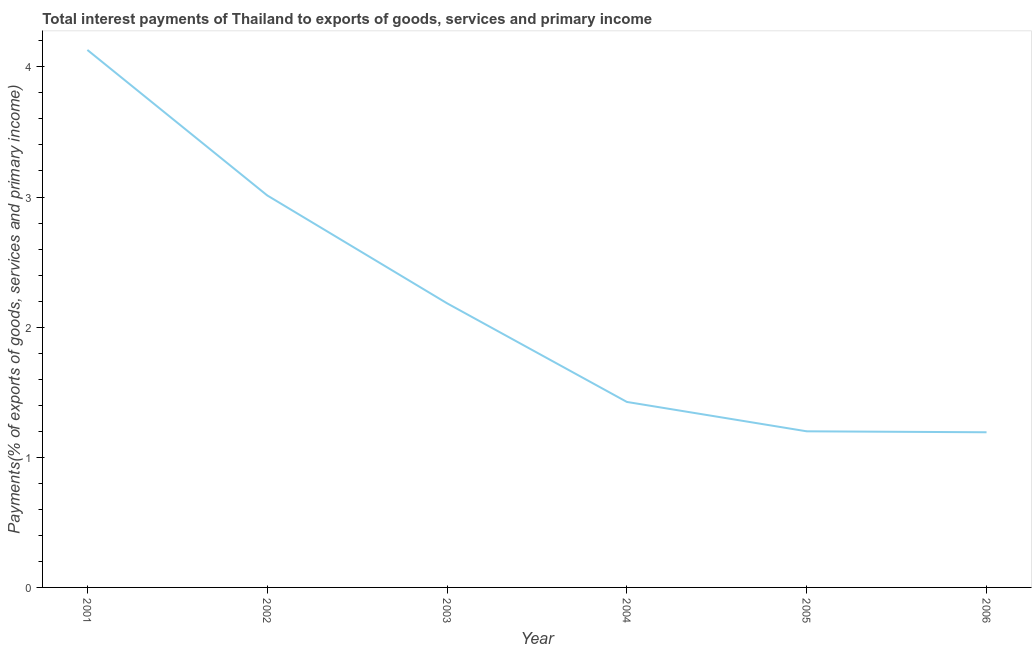What is the total interest payments on external debt in 2001?
Your answer should be compact. 4.13. Across all years, what is the maximum total interest payments on external debt?
Provide a short and direct response. 4.13. Across all years, what is the minimum total interest payments on external debt?
Give a very brief answer. 1.19. In which year was the total interest payments on external debt maximum?
Provide a succinct answer. 2001. In which year was the total interest payments on external debt minimum?
Offer a very short reply. 2006. What is the sum of the total interest payments on external debt?
Offer a terse response. 13.14. What is the difference between the total interest payments on external debt in 2001 and 2004?
Your answer should be compact. 2.7. What is the average total interest payments on external debt per year?
Give a very brief answer. 2.19. What is the median total interest payments on external debt?
Provide a short and direct response. 1.8. In how many years, is the total interest payments on external debt greater than 2.6 %?
Provide a succinct answer. 2. What is the ratio of the total interest payments on external debt in 2003 to that in 2005?
Provide a short and direct response. 1.82. Is the total interest payments on external debt in 2003 less than that in 2006?
Your response must be concise. No. What is the difference between the highest and the second highest total interest payments on external debt?
Give a very brief answer. 1.12. Is the sum of the total interest payments on external debt in 2002 and 2004 greater than the maximum total interest payments on external debt across all years?
Offer a very short reply. Yes. What is the difference between the highest and the lowest total interest payments on external debt?
Make the answer very short. 2.94. In how many years, is the total interest payments on external debt greater than the average total interest payments on external debt taken over all years?
Your answer should be compact. 2. Does the total interest payments on external debt monotonically increase over the years?
Keep it short and to the point. No. How many lines are there?
Ensure brevity in your answer.  1. How many years are there in the graph?
Offer a terse response. 6. Are the values on the major ticks of Y-axis written in scientific E-notation?
Ensure brevity in your answer.  No. Does the graph contain any zero values?
Make the answer very short. No. What is the title of the graph?
Provide a succinct answer. Total interest payments of Thailand to exports of goods, services and primary income. What is the label or title of the X-axis?
Your answer should be very brief. Year. What is the label or title of the Y-axis?
Your answer should be compact. Payments(% of exports of goods, services and primary income). What is the Payments(% of exports of goods, services and primary income) of 2001?
Provide a succinct answer. 4.13. What is the Payments(% of exports of goods, services and primary income) of 2002?
Offer a terse response. 3.01. What is the Payments(% of exports of goods, services and primary income) in 2003?
Your answer should be very brief. 2.18. What is the Payments(% of exports of goods, services and primary income) of 2004?
Offer a very short reply. 1.43. What is the Payments(% of exports of goods, services and primary income) of 2005?
Your answer should be compact. 1.2. What is the Payments(% of exports of goods, services and primary income) in 2006?
Make the answer very short. 1.19. What is the difference between the Payments(% of exports of goods, services and primary income) in 2001 and 2002?
Offer a terse response. 1.12. What is the difference between the Payments(% of exports of goods, services and primary income) in 2001 and 2003?
Keep it short and to the point. 1.95. What is the difference between the Payments(% of exports of goods, services and primary income) in 2001 and 2004?
Your response must be concise. 2.7. What is the difference between the Payments(% of exports of goods, services and primary income) in 2001 and 2005?
Your response must be concise. 2.93. What is the difference between the Payments(% of exports of goods, services and primary income) in 2001 and 2006?
Keep it short and to the point. 2.94. What is the difference between the Payments(% of exports of goods, services and primary income) in 2002 and 2003?
Your response must be concise. 0.83. What is the difference between the Payments(% of exports of goods, services and primary income) in 2002 and 2004?
Your answer should be compact. 1.59. What is the difference between the Payments(% of exports of goods, services and primary income) in 2002 and 2005?
Your answer should be compact. 1.81. What is the difference between the Payments(% of exports of goods, services and primary income) in 2002 and 2006?
Your answer should be compact. 1.82. What is the difference between the Payments(% of exports of goods, services and primary income) in 2003 and 2004?
Your response must be concise. 0.76. What is the difference between the Payments(% of exports of goods, services and primary income) in 2003 and 2005?
Provide a succinct answer. 0.98. What is the difference between the Payments(% of exports of goods, services and primary income) in 2004 and 2005?
Offer a terse response. 0.23. What is the difference between the Payments(% of exports of goods, services and primary income) in 2004 and 2006?
Ensure brevity in your answer.  0.23. What is the difference between the Payments(% of exports of goods, services and primary income) in 2005 and 2006?
Your response must be concise. 0.01. What is the ratio of the Payments(% of exports of goods, services and primary income) in 2001 to that in 2002?
Offer a terse response. 1.37. What is the ratio of the Payments(% of exports of goods, services and primary income) in 2001 to that in 2003?
Make the answer very short. 1.89. What is the ratio of the Payments(% of exports of goods, services and primary income) in 2001 to that in 2004?
Give a very brief answer. 2.9. What is the ratio of the Payments(% of exports of goods, services and primary income) in 2001 to that in 2005?
Provide a succinct answer. 3.44. What is the ratio of the Payments(% of exports of goods, services and primary income) in 2001 to that in 2006?
Give a very brief answer. 3.46. What is the ratio of the Payments(% of exports of goods, services and primary income) in 2002 to that in 2003?
Your answer should be compact. 1.38. What is the ratio of the Payments(% of exports of goods, services and primary income) in 2002 to that in 2004?
Provide a short and direct response. 2.11. What is the ratio of the Payments(% of exports of goods, services and primary income) in 2002 to that in 2005?
Make the answer very short. 2.51. What is the ratio of the Payments(% of exports of goods, services and primary income) in 2002 to that in 2006?
Provide a short and direct response. 2.53. What is the ratio of the Payments(% of exports of goods, services and primary income) in 2003 to that in 2004?
Give a very brief answer. 1.53. What is the ratio of the Payments(% of exports of goods, services and primary income) in 2003 to that in 2005?
Offer a very short reply. 1.82. What is the ratio of the Payments(% of exports of goods, services and primary income) in 2003 to that in 2006?
Give a very brief answer. 1.83. What is the ratio of the Payments(% of exports of goods, services and primary income) in 2004 to that in 2005?
Provide a short and direct response. 1.19. What is the ratio of the Payments(% of exports of goods, services and primary income) in 2004 to that in 2006?
Ensure brevity in your answer.  1.2. What is the ratio of the Payments(% of exports of goods, services and primary income) in 2005 to that in 2006?
Your answer should be compact. 1.01. 